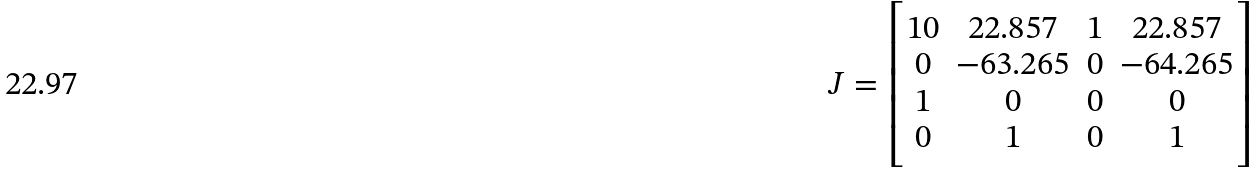Convert formula to latex. <formula><loc_0><loc_0><loc_500><loc_500>J = \begin{bmatrix} 1 0 & 2 2 . 8 5 7 & 1 & 2 2 . 8 5 7 \\ 0 & - 6 3 . 2 6 5 & 0 & - 6 4 . 2 6 5 \\ 1 & 0 & 0 & 0 \\ 0 & 1 & 0 & 1 \end{bmatrix}</formula> 